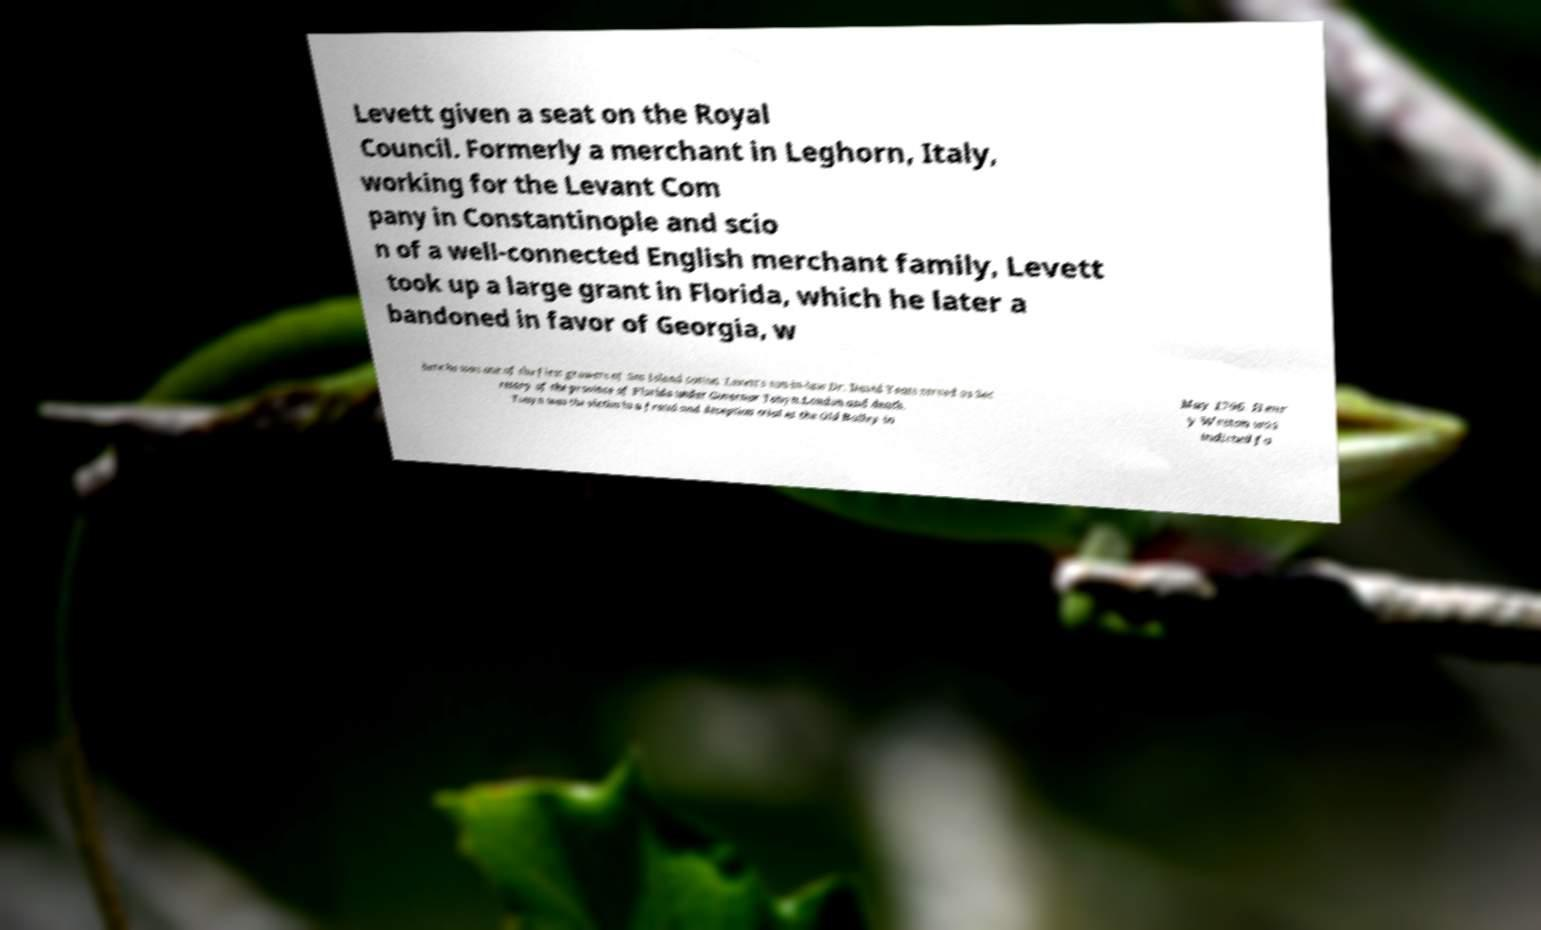I need the written content from this picture converted into text. Can you do that? Levett given a seat on the Royal Council. Formerly a merchant in Leghorn, Italy, working for the Levant Com pany in Constantinople and scio n of a well-connected English merchant family, Levett took up a large grant in Florida, which he later a bandoned in favor of Georgia, w here he was one of the first growers of Sea Island cotton. Levett's son-in-law Dr. David Yeats served as Sec retary of the province of Florida under Governor Tonyn.London and death. Tonyn was the victim in a fraud and deception trial at the Old Bailey in May 1796. Henr y Weston was indicted fo 